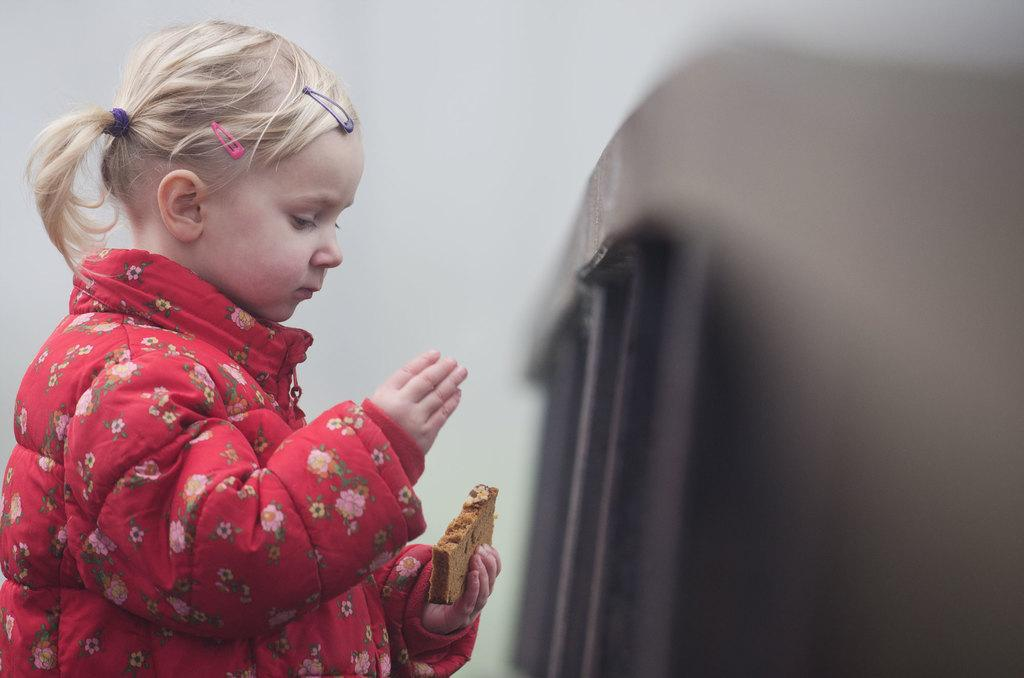What is the main subject of the image? The main subject of the image is a child. What is the child holding in the image? The child is holding a piece of bread. What can be seen on the right side of the image? There is a barricade on the right side of the image. Can you see a crowd gathered around the child in the image? No, there is no crowd present in the image. Is the child playing a guitar in the image? No, the child is not playing a guitar in the image; they are holding a piece of bread. 